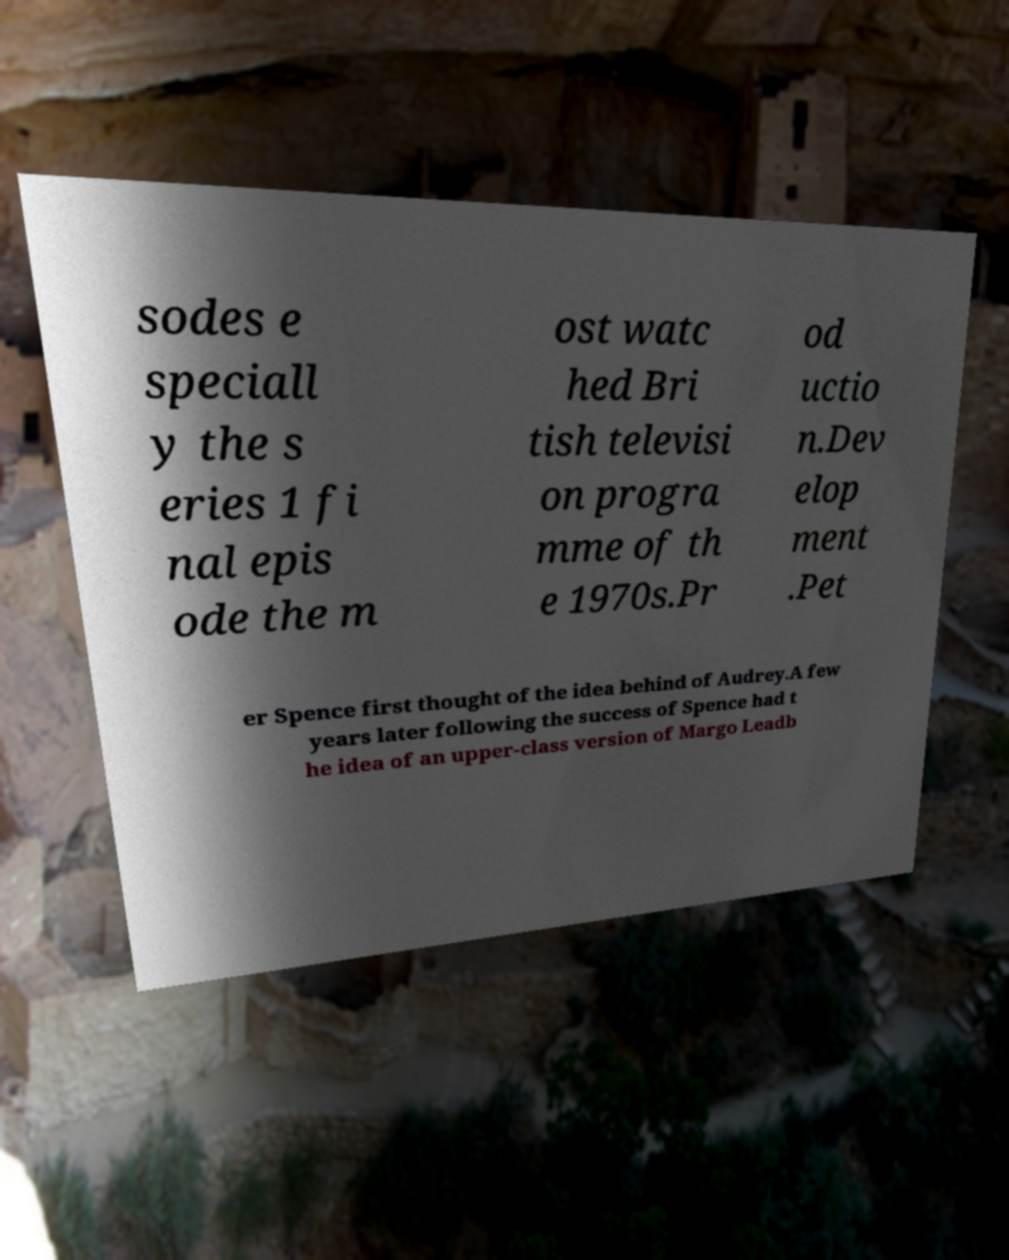Can you accurately transcribe the text from the provided image for me? sodes e speciall y the s eries 1 fi nal epis ode the m ost watc hed Bri tish televisi on progra mme of th e 1970s.Pr od uctio n.Dev elop ment .Pet er Spence first thought of the idea behind of Audrey.A few years later following the success of Spence had t he idea of an upper-class version of Margo Leadb 